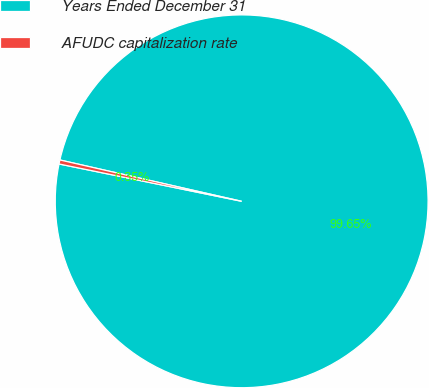Convert chart. <chart><loc_0><loc_0><loc_500><loc_500><pie_chart><fcel>Years Ended December 31<fcel>AFUDC capitalization rate<nl><fcel>99.65%<fcel>0.35%<nl></chart> 